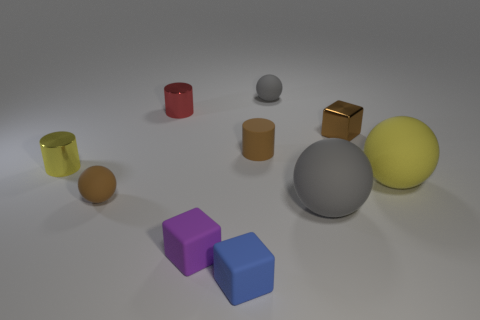Subtract all green balls. Subtract all purple cubes. How many balls are left? 4 Subtract all cubes. How many objects are left? 7 Subtract all blue metallic blocks. Subtract all small red things. How many objects are left? 9 Add 4 brown matte objects. How many brown matte objects are left? 6 Add 5 large rubber spheres. How many large rubber spheres exist? 7 Subtract 1 brown spheres. How many objects are left? 9 